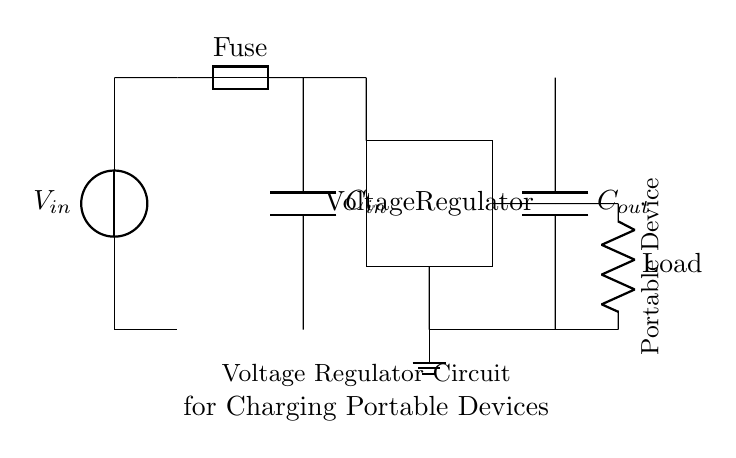What is the function of the fuse in this circuit? The fuse serves to protect the circuit from overcurrent conditions. If the current exceeds a certain threshold, the fuse will blow, breaking the circuit and preventing damage to other components.
Answer: Protects from overcurrent What type of capacitors are used in this circuit? The circuit diagram shows two capacitors, labeled as C in and C out, which are typically electrolytic or ceramic capacitors. Their function is to stabilize voltage and filter out noise in the circuit.
Answer: Capacitors How many input connections are present in this circuit? There are two input connections: one for the voltage source and the other is just a short connected to ground, which indicates the common return path for the current.
Answer: Two What is the load in this circuit? The load is indicated by a resistor labeled 'Load' in the circuit, which simulates the portable device being charged or powered by the circuit.
Answer: Load Why is a voltage regulator used in this circuit? The voltage regulator is essential to ensure that the voltage supplied to the portable devices remains stable regardless of variations in input voltage or output load conditions. This prevents the devices from being damaged due to overvoltage.
Answer: Ensures stable voltage What components connect the input to the output of the voltage regulator? The connections consist of a fuse and two capacitors (C in and C out) that stabilize and condition the voltage before and after regulation, ensuring that the output is clean and safe for the load.
Answer: Fuse and capacitors 